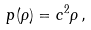Convert formula to latex. <formula><loc_0><loc_0><loc_500><loc_500>p ( \rho ) = c ^ { 2 } \rho \, ,</formula> 